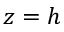Convert formula to latex. <formula><loc_0><loc_0><loc_500><loc_500>z = h</formula> 